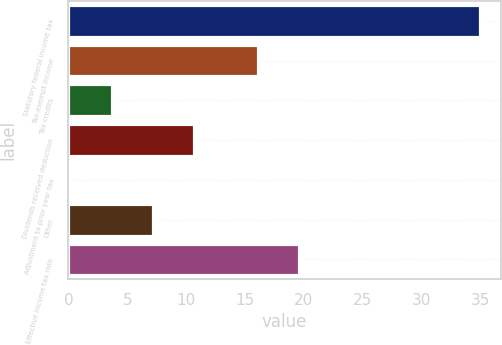Convert chart. <chart><loc_0><loc_0><loc_500><loc_500><bar_chart><fcel>Statutory federal income tax<fcel>Tax-exempt income<fcel>Tax credits<fcel>Dividends received deduction<fcel>Adjustment to prior year tax<fcel>Other<fcel>Effective income tax rate<nl><fcel>35<fcel>16.1<fcel>3.68<fcel>10.64<fcel>0.2<fcel>7.16<fcel>19.58<nl></chart> 